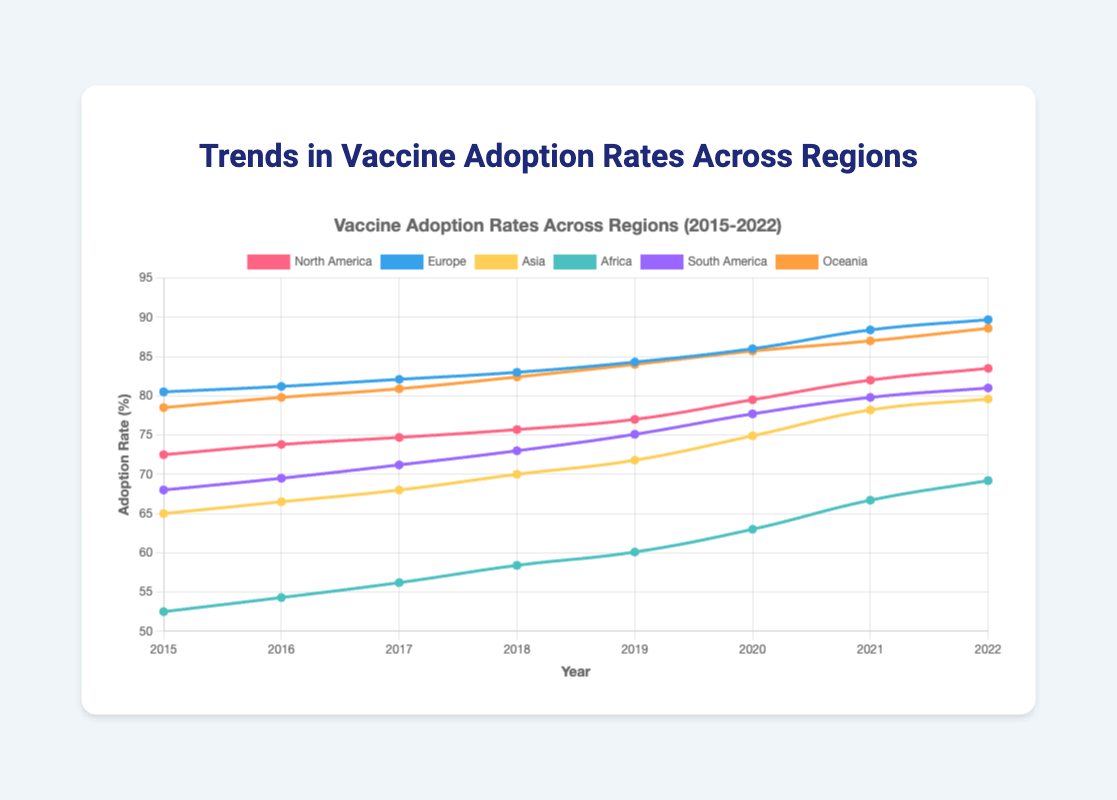Which region had the highest vaccine adoption rate in 2022? To determine which region had the highest vaccine adoption rate in 2022, we check the plotted data points for each region at the year 2022. The highest point corresponds to Europe with a rate of 89.7%.
Answer: Europe What is the difference in vaccine adoption rates between Asia and Africa in 2021? For Asia, the adoption rate in 2021 is 78.2%. For Africa, the adoption rate in 2021 is 66.7%. The difference is calculated as 78.2% - 66.7% = 11.5%.
Answer: 11.5% Which region showed the smallest increase in vaccine adoption rates from 2015 to 2022? By observing the distance between the initial (2015) and final (2022) points for each region, it is clear that North America had the smallest increase. North America's adoption rate went from 72.5% to 83.5%, an increase of 11.0%. Other regions had higher increases.
Answer: North America What is the average annual vaccine adoption rate increase for South America from 2015 to 2022? First, find the total increase in adoption rate from 2015 (68.0%) to 2022 (81.0%): 81.0% - 68.0% = 13.0%. There are 7 years between 2015 and 2022. The average annual increase is 13.0% / 7 ≈ 1.86%.
Answer: 1.86% In which year did North America cross a 75% adoption rate? By examining the data points for North America, we see that the adoption rate crosses 75% between 2017 (74.7%) and 2018 (75.7%). Thus, North America crossed the 75% adoption rate in 2018.
Answer: 2018 Compare the trends of Europe and Oceania from 2018 to 2022. Which region had a steeper increase and by how much? For Europe, the adoption rate increased from 83.0% in 2018 to 89.7% in 2022, a total increase of 6.7%. For Oceania, the rate went from 82.4% to 88.6%, an increase of 6.2%. Europe had a steeper increase by 6.7% - 6.2% = 0.5%.
Answer: Europe, 0.5% What visual feature distinguishes the highest adoption rates in 2022 on the chart? The highest adoption rates in 2022 can be distinguished by checking which lines reach the highest point on the y-axis. In this case, the blue line representing Europe and the green line representing Oceania are closest to the top of the y-axis around the 89-90% range.
Answer: Blue and Green lines near the top What are the combined adoption rates of North America and Asia in 2020? In 2020, the adoption rate for North America is 79.5%, and for Asia, it is 74.9%. Adding these together gives 79.5% + 74.9% = 154.4%.
Answer: 154.4% Which region exhibited the most consistent year-over-year increase in vaccine adoption rates from 2015 to 2022? Examining the chart for consistency in the upward trend, Europe shows the most consistent increases with a steady rise each year from 80.5% in 2015 to 89.7% in 2022. Other regions show small variations or steeper increases in certain years.
Answer: Europe 